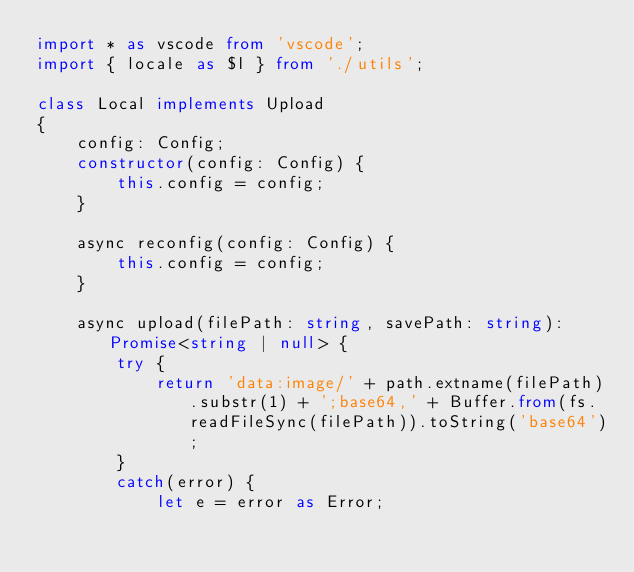<code> <loc_0><loc_0><loc_500><loc_500><_TypeScript_>import * as vscode from 'vscode';
import { locale as $l } from './utils';

class Local implements Upload
{
    config: Config;
    constructor(config: Config) {
        this.config = config;
    }

    async reconfig(config: Config) {
        this.config = config;
    }

    async upload(filePath: string, savePath: string): Promise<string | null> {
        try {
            return 'data:image/' + path.extname(filePath).substr(1) + ';base64,' + Buffer.from(fs.readFileSync(filePath)).toString('base64');
        }
        catch(error) {
            let e = error as Error;</code> 